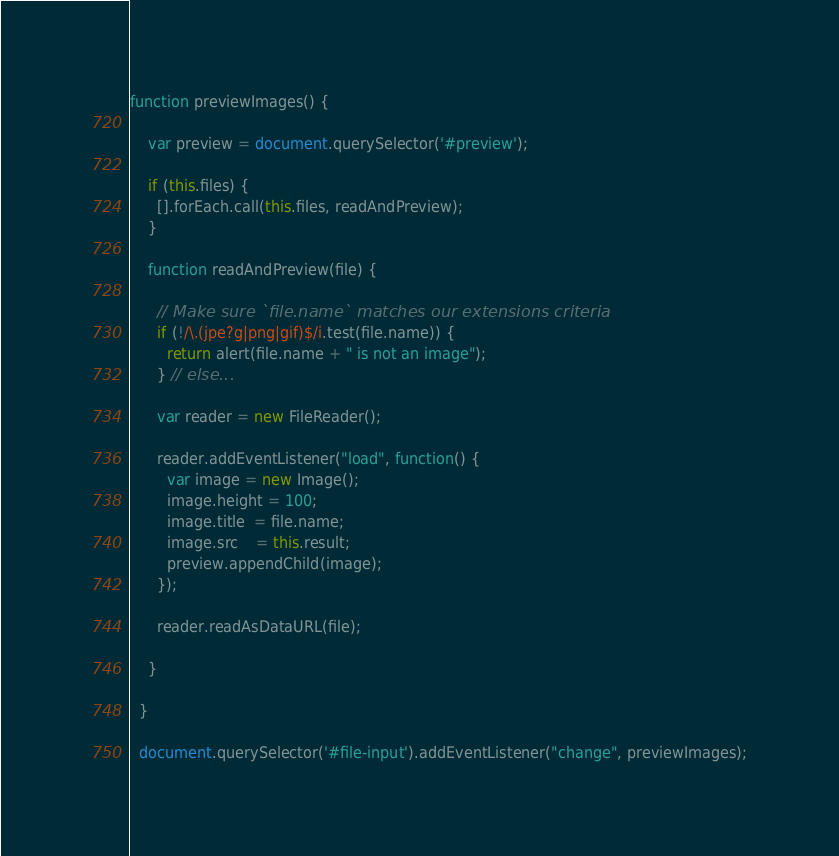<code> <loc_0><loc_0><loc_500><loc_500><_JavaScript_>function previewImages() {

    var preview = document.querySelector('#preview');
    
    if (this.files) {
      [].forEach.call(this.files, readAndPreview);
    }
  
    function readAndPreview(file) {
  
      // Make sure `file.name` matches our extensions criteria
      if (!/\.(jpe?g|png|gif)$/i.test(file.name)) {
        return alert(file.name + " is not an image");
      } // else...
      
      var reader = new FileReader();
      
      reader.addEventListener("load", function() {
        var image = new Image();
        image.height = 100;
        image.title  = file.name;
        image.src    = this.result;
        preview.appendChild(image);
      });
      
      reader.readAsDataURL(file);
      
    }
  
  }
  
  document.querySelector('#file-input').addEventListener("change", previewImages);</code> 